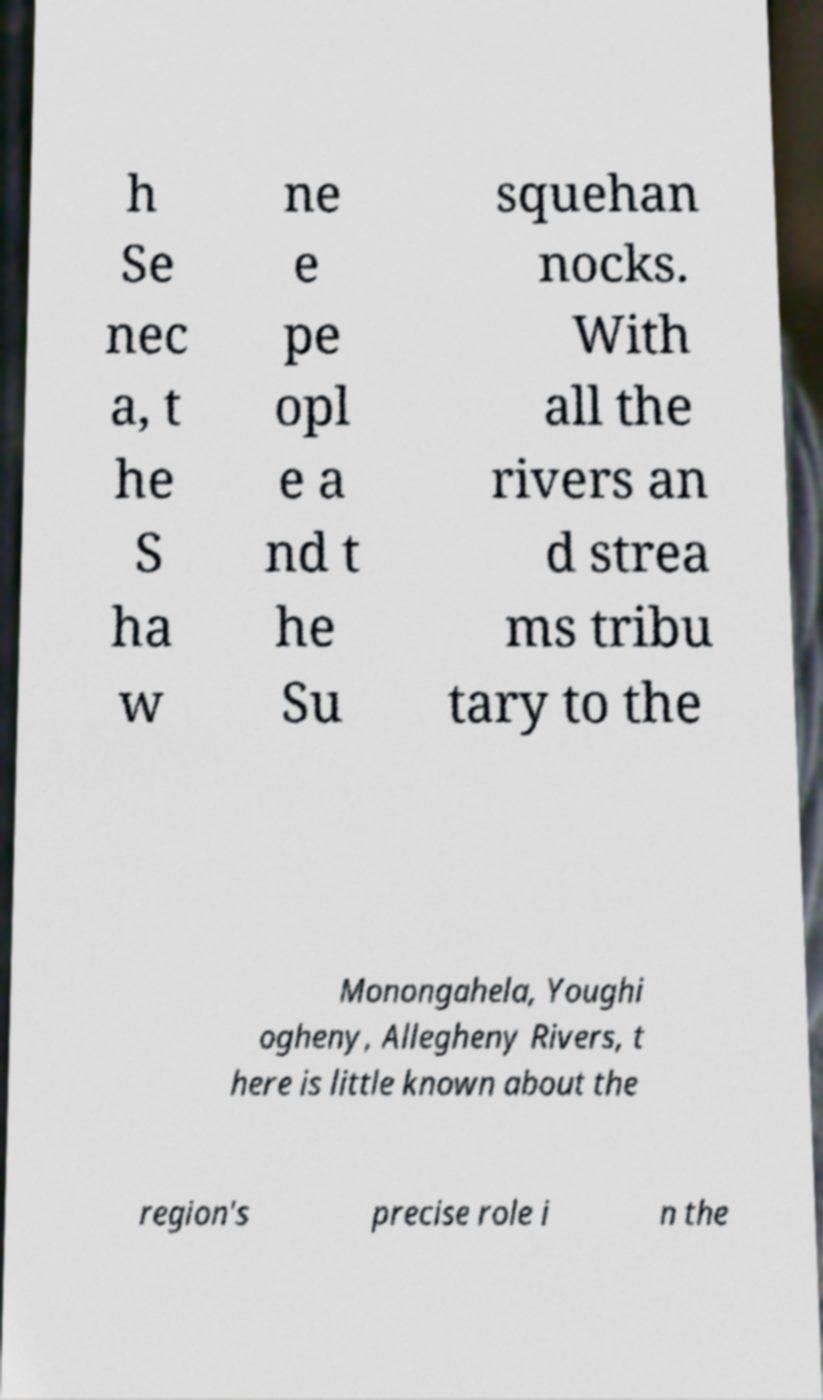Can you accurately transcribe the text from the provided image for me? h Se nec a, t he S ha w ne e pe opl e a nd t he Su squehan nocks. With all the rivers an d strea ms tribu tary to the Monongahela, Youghi ogheny, Allegheny Rivers, t here is little known about the region's precise role i n the 